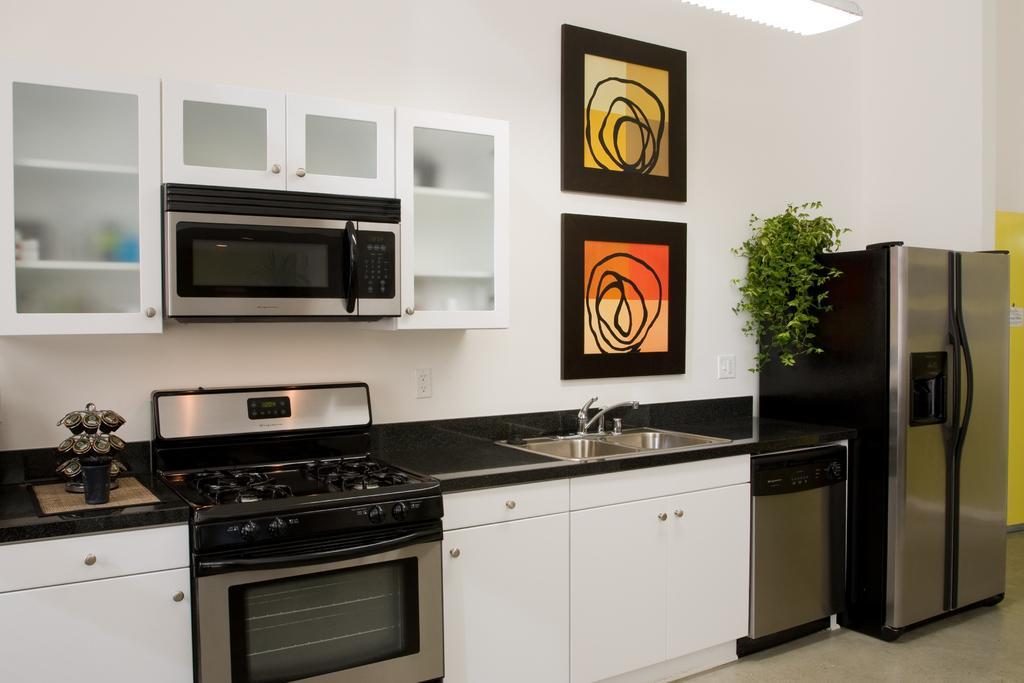Describe this image in one or two sentences. In the image we can see a refrigerator, plant, wash basin, water tap, frames stick to the wall, stove, oven, cupboards, wall and floor. 